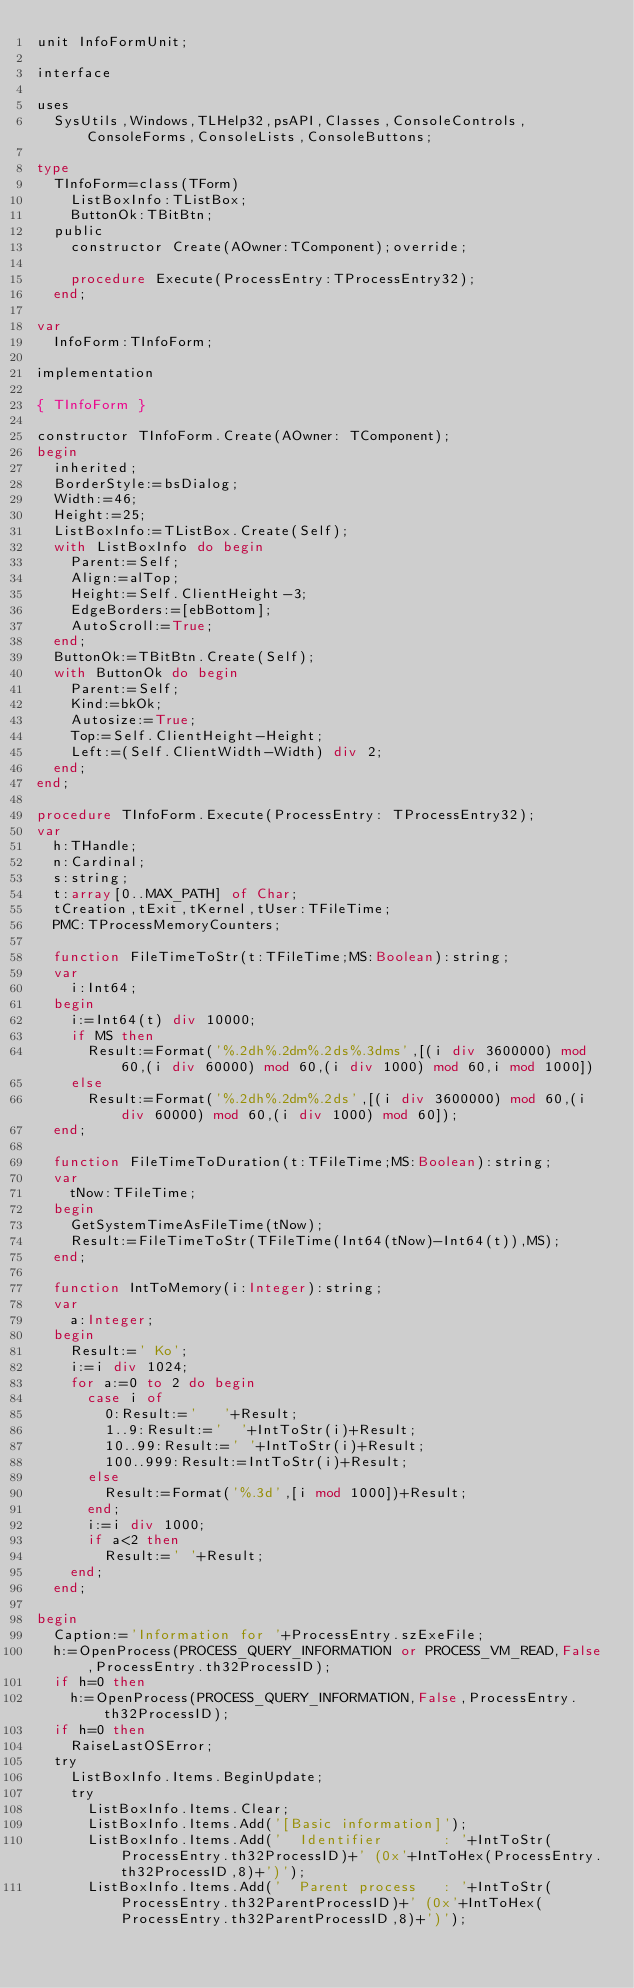Convert code to text. <code><loc_0><loc_0><loc_500><loc_500><_Pascal_>unit InfoFormUnit;

interface

uses
  SysUtils,Windows,TLHelp32,psAPI,Classes,ConsoleControls,ConsoleForms,ConsoleLists,ConsoleButtons;

type
  TInfoForm=class(TForm)
    ListBoxInfo:TListBox;
    ButtonOk:TBitBtn;
  public
    constructor Create(AOwner:TComponent);override;

    procedure Execute(ProcessEntry:TProcessEntry32);
  end;

var
  InfoForm:TInfoForm;

implementation

{ TInfoForm }

constructor TInfoForm.Create(AOwner: TComponent);
begin
  inherited;
  BorderStyle:=bsDialog;
  Width:=46;
  Height:=25;
  ListBoxInfo:=TListBox.Create(Self);
  with ListBoxInfo do begin
    Parent:=Self;
    Align:=alTop;
    Height:=Self.ClientHeight-3;
    EdgeBorders:=[ebBottom];
    AutoScroll:=True;
  end;
  ButtonOk:=TBitBtn.Create(Self);
  with ButtonOk do begin
    Parent:=Self;
    Kind:=bkOk;
    Autosize:=True;
    Top:=Self.ClientHeight-Height;
    Left:=(Self.ClientWidth-Width) div 2;
  end;
end;

procedure TInfoForm.Execute(ProcessEntry: TProcessEntry32);
var
  h:THandle;
  n:Cardinal;
  s:string;
  t:array[0..MAX_PATH] of Char;
  tCreation,tExit,tKernel,tUser:TFileTime;
  PMC:TProcessMemoryCounters;

  function FileTimeToStr(t:TFileTime;MS:Boolean):string;
  var
    i:Int64;
  begin
    i:=Int64(t) div 10000;
    if MS then
      Result:=Format('%.2dh%.2dm%.2ds%.3dms',[(i div 3600000) mod 60,(i div 60000) mod 60,(i div 1000) mod 60,i mod 1000])
    else
      Result:=Format('%.2dh%.2dm%.2ds',[(i div 3600000) mod 60,(i div 60000) mod 60,(i div 1000) mod 60]);
  end;

  function FileTimeToDuration(t:TFileTime;MS:Boolean):string;
  var
    tNow:TFileTime;
  begin
    GetSystemTimeAsFileTime(tNow);
    Result:=FileTimeToStr(TFileTime(Int64(tNow)-Int64(t)),MS);
  end;

  function IntToMemory(i:Integer):string;
  var
    a:Integer;
  begin
    Result:=' Ko';
    i:=i div 1024;
    for a:=0 to 2 do begin
      case i of
        0:Result:='   '+Result;
        1..9:Result:='  '+IntToStr(i)+Result;
        10..99:Result:=' '+IntToStr(i)+Result;
        100..999:Result:=IntToStr(i)+Result;
      else
        Result:=Format('%.3d',[i mod 1000])+Result;
      end;
      i:=i div 1000;
      if a<2 then
        Result:=' '+Result;
    end;
  end;
  
begin
  Caption:='Information for '+ProcessEntry.szExeFile;
  h:=OpenProcess(PROCESS_QUERY_INFORMATION or PROCESS_VM_READ,False,ProcessEntry.th32ProcessID);
  if h=0 then
    h:=OpenProcess(PROCESS_QUERY_INFORMATION,False,ProcessEntry.th32ProcessID);
  if h=0 then
    RaiseLastOSError;
  try
    ListBoxInfo.Items.BeginUpdate;
    try
      ListBoxInfo.Items.Clear;
      ListBoxInfo.Items.Add('[Basic information]');
      ListBoxInfo.Items.Add('  Identifier       : '+IntToStr(ProcessEntry.th32ProcessID)+' (0x'+IntToHex(ProcessEntry.th32ProcessID,8)+')');
      ListBoxInfo.Items.Add('  Parent process   : '+IntToStr(ProcessEntry.th32ParentProcessID)+' (0x'+IntToHex(ProcessEntry.th32ParentProcessID,8)+')');</code> 